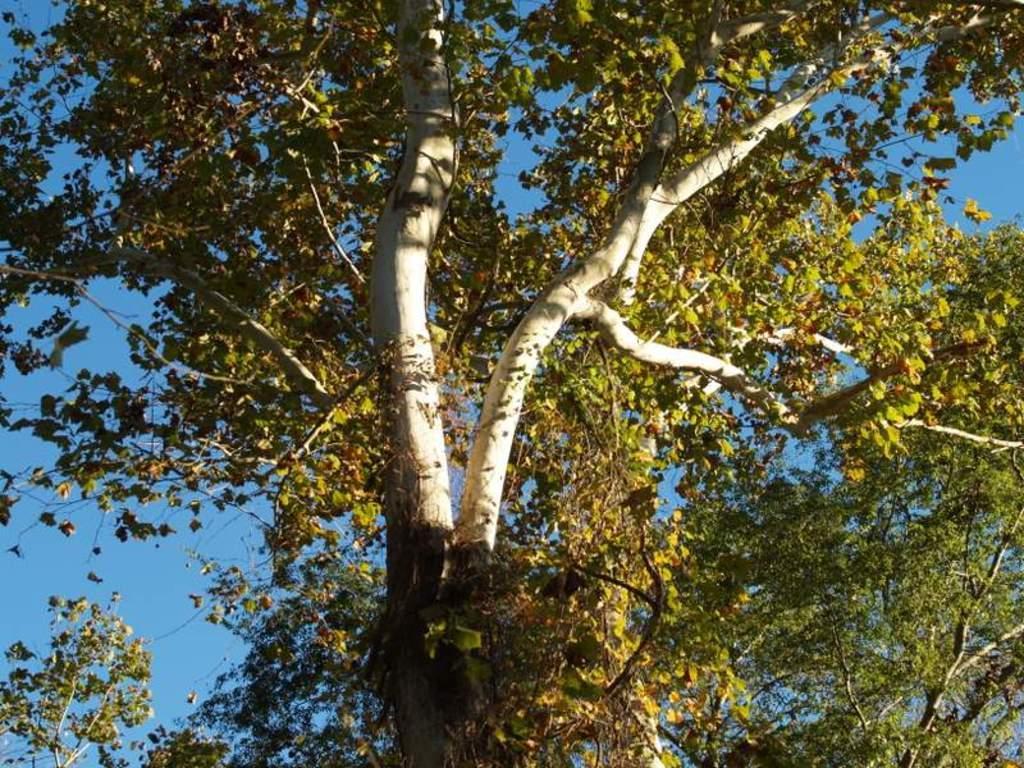Could you give a brief overview of what you see in this image? In this picture I can observe trees. In the background there is a sky. 